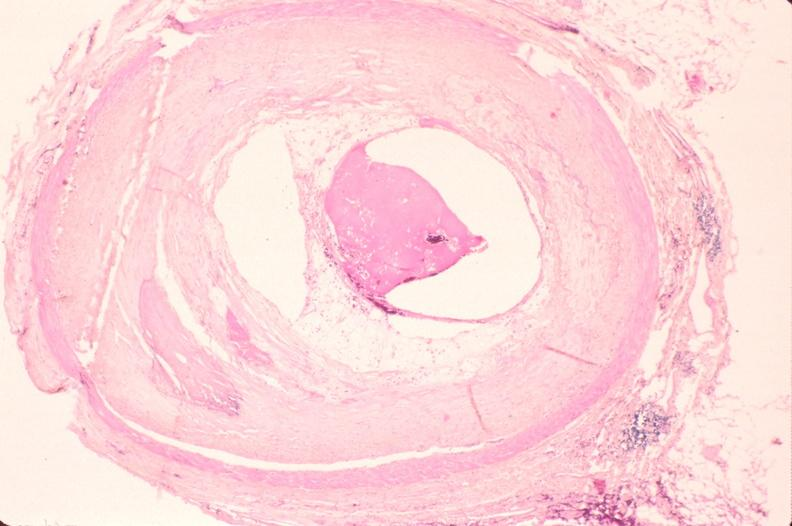what is present?
Answer the question using a single word or phrase. Vasculature 